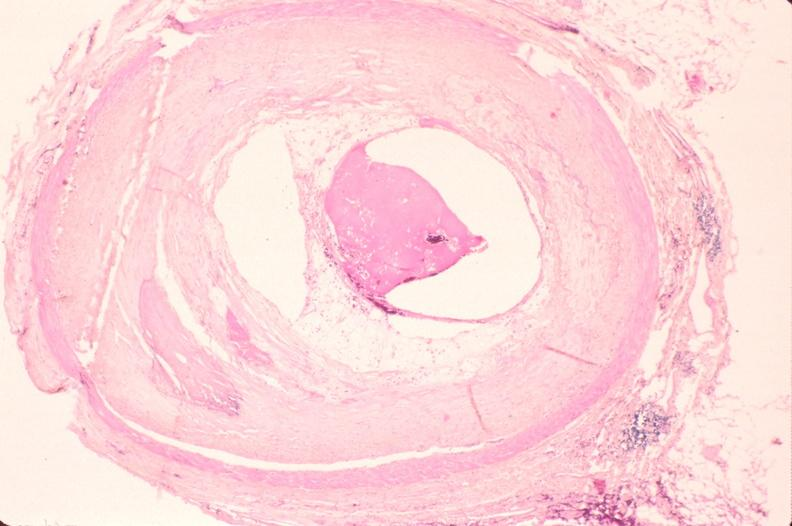what is present?
Answer the question using a single word or phrase. Vasculature 